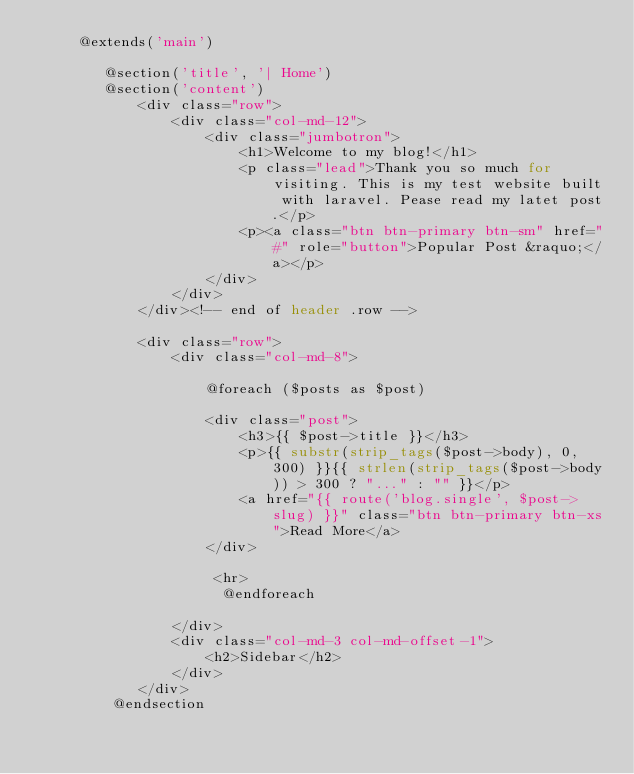Convert code to text. <code><loc_0><loc_0><loc_500><loc_500><_PHP_>     @extends('main')

        @section('title', '| Home')
        @section('content')
            <div class="row">
                <div class="col-md-12">
                    <div class="jumbotron">
                        <h1>Welcome to my blog!</h1>
                        <p class="lead">Thank you so much for visiting. This is my test website built with laravel. Pease read my latet post.</p>
                        <p><a class="btn btn-primary btn-sm" href="#" role="button">Popular Post &raquo;</a></p>
                    </div>
                </div>
            </div><!-- end of header .row -->

            <div class="row">
                <div class="col-md-8">

                    @foreach ($posts as $post)

                    <div class="post">
                        <h3>{{ $post->title }}</h3>
                        <p>{{ substr(strip_tags($post->body), 0, 300) }}{{ strlen(strip_tags($post->body)) > 300 ? "..." : "" }}</p>
                        <a href="{{ route('blog.single', $post->slug) }}" class="btn btn-primary btn-xs">Read More</a>
                    </div>

                     <hr>
                      @endforeach

                </div>
                <div class="col-md-3 col-md-offset-1">
                    <h2>Sidebar</h2>
                </div>
            </div>
         @endsection
</code> 